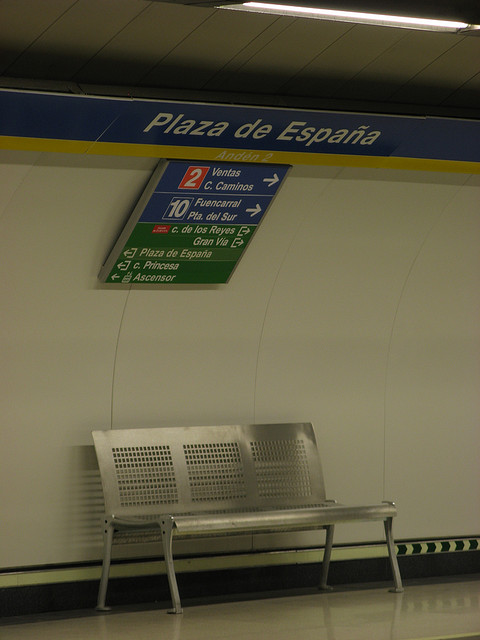How many benches are in the picture? There is one bench in the picture, located just beneath a sign that appears to be indicating directions at a transportation hub. 